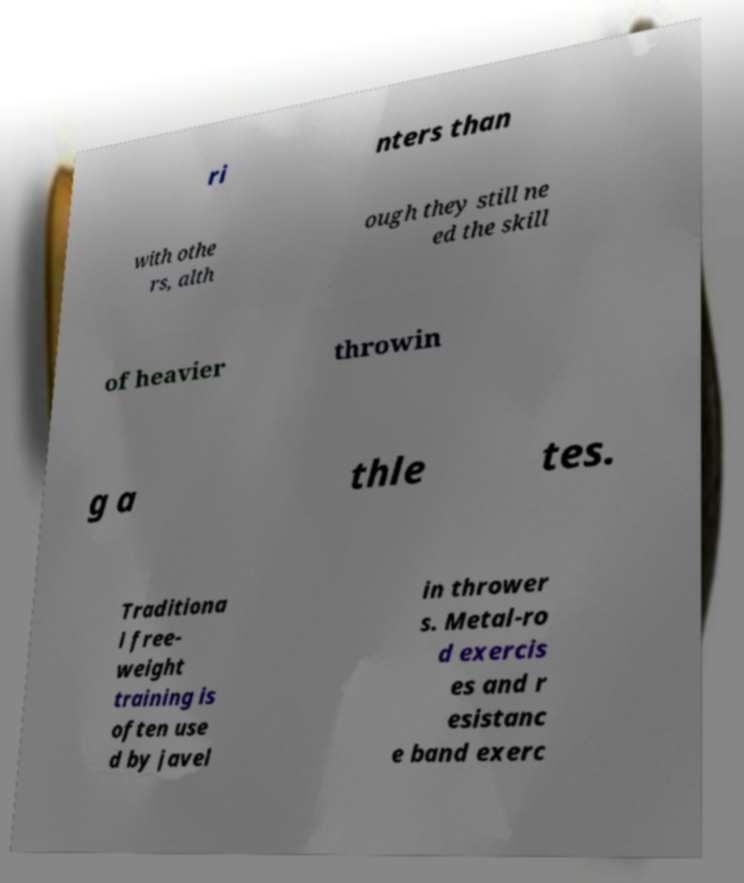There's text embedded in this image that I need extracted. Can you transcribe it verbatim? ri nters than with othe rs, alth ough they still ne ed the skill of heavier throwin g a thle tes. Traditiona l free- weight training is often use d by javel in thrower s. Metal-ro d exercis es and r esistanc e band exerc 